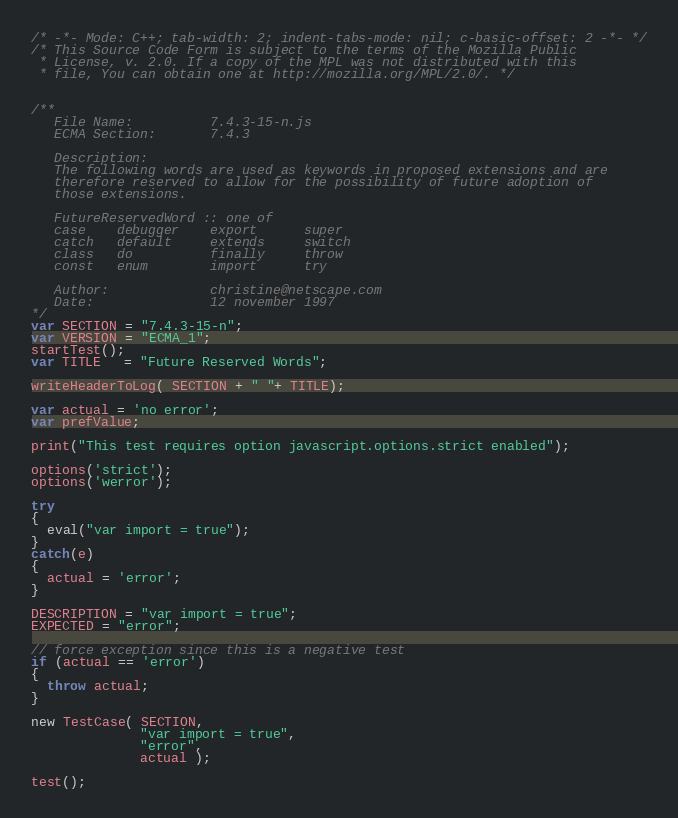<code> <loc_0><loc_0><loc_500><loc_500><_JavaScript_>/* -*- Mode: C++; tab-width: 2; indent-tabs-mode: nil; c-basic-offset: 2 -*- */
/* This Source Code Form is subject to the terms of the Mozilla Public
 * License, v. 2.0. If a copy of the MPL was not distributed with this
 * file, You can obtain one at http://mozilla.org/MPL/2.0/. */


/**
   File Name:          7.4.3-15-n.js
   ECMA Section:       7.4.3

   Description:
   The following words are used as keywords in proposed extensions and are
   therefore reserved to allow for the possibility of future adoption of
   those extensions.

   FutureReservedWord :: one of
   case    debugger    export      super
   catch   default     extends     switch
   class   do          finally     throw
   const   enum        import      try

   Author:             christine@netscape.com
   Date:               12 november 1997
*/
var SECTION = "7.4.3-15-n";
var VERSION = "ECMA_1";
startTest();
var TITLE   = "Future Reserved Words";

writeHeaderToLog( SECTION + " "+ TITLE);

var actual = 'no error';
var prefValue;

print("This test requires option javascript.options.strict enabled");

options('strict');
options('werror');

try
{
  eval("var import = true");
}
catch(e)
{
  actual = 'error';
}

DESCRIPTION = "var import = true";
EXPECTED = "error";

// force exception since this is a negative test
if (actual == 'error')
{
  throw actual;
}

new TestCase( SECTION, 
              "var import = true",    
              "error",   
              actual );

test();
</code> 